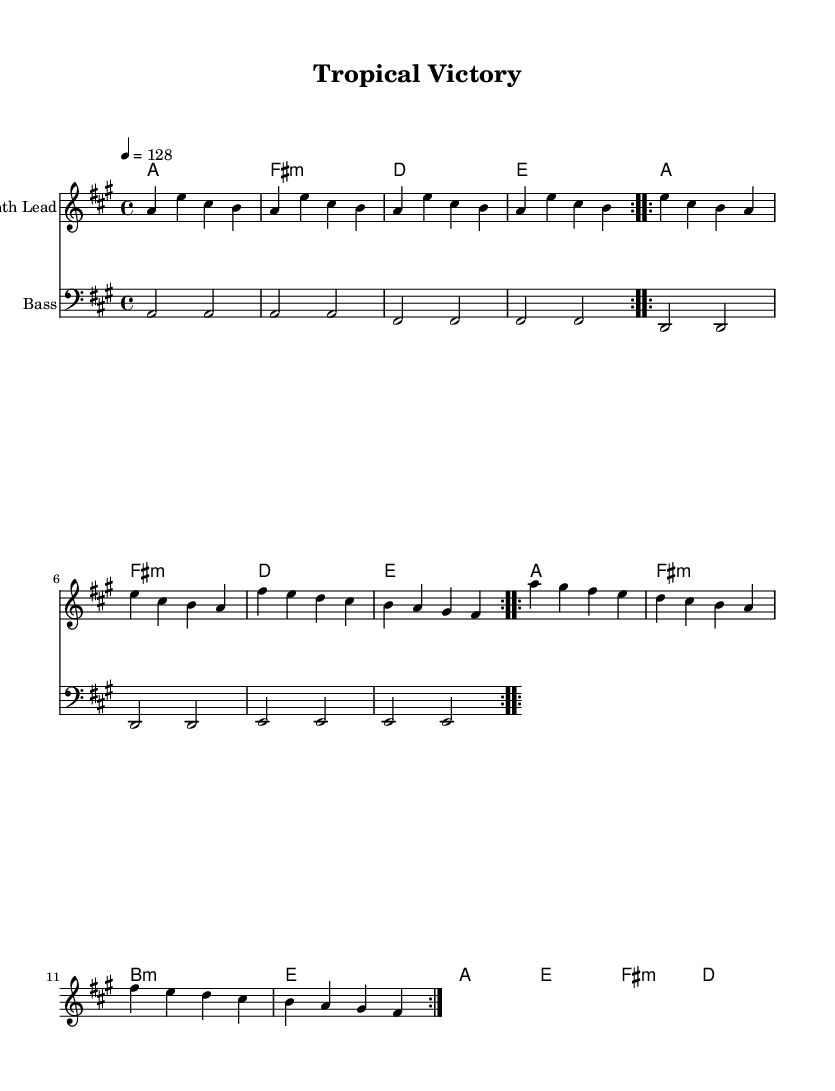What is the key signature of this music? The key signature is A major, which has three sharps: F#, C#, and G#. This can be identified from the global section of the sheet music where the key is indicated.
Answer: A major What is the time signature of the piece? The time signature is 4/4, indicating that each measure contains four beats, and each quarter note is one beat. This is specified in the global section of the sheet music.
Answer: 4/4 What is the tempo marking for this piece? The tempo marking is 128 beats per minute, indicated in the global section of the sheet music. It means the music is intended to be played at this speed.
Answer: 128 How many volta do the melody sections have? The melody sections contain 6 total repeats: 2 for each of the three main segments in the melody indicated by "repeat volta 2." This shows that each segment is meant to be played twice.
Answer: 6 What type of chords are used in the harmony section? The chord types include major and minor chords, specifically A major, F# minor, D major, E major, and B minor. These chord qualities are indicated by the chord symbols written under the staff.
Answer: Major and minor What instrument is indicated for the melody? The instrument specified for the melody is "Synth Lead," as mentioned in the header of the corresponding staff. This indicates that the melody line is intended to be played using a synthesizer lead sound.
Answer: Synth Lead What is the bass clef used for in this music? The bass clef is used to denote the lower pitch range for bass instruments, and it is indicated right before the bass staff. Here, it provides a visual cue for the player to understand they are playing lower notes.
Answer: Bass 